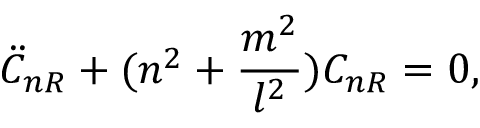<formula> <loc_0><loc_0><loc_500><loc_500>\ddot { C } _ { n R } + ( n ^ { 2 } + \frac { m ^ { 2 } } { l ^ { 2 } } ) C _ { n R } = 0 ,</formula> 